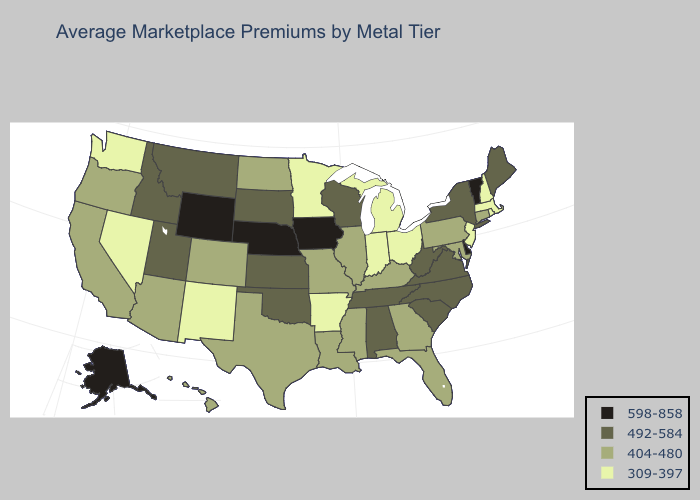Among the states that border New York , which have the highest value?
Give a very brief answer. Vermont. Which states have the highest value in the USA?
Give a very brief answer. Alaska, Delaware, Iowa, Nebraska, Vermont, Wyoming. Does Mississippi have a higher value than Virginia?
Answer briefly. No. Name the states that have a value in the range 404-480?
Quick response, please. Arizona, California, Colorado, Connecticut, Florida, Georgia, Hawaii, Illinois, Kentucky, Louisiana, Maryland, Mississippi, Missouri, North Dakota, Oregon, Pennsylvania, Texas. Does Indiana have the highest value in the MidWest?
Answer briefly. No. What is the value of Louisiana?
Short answer required. 404-480. Name the states that have a value in the range 309-397?
Keep it brief. Arkansas, Indiana, Massachusetts, Michigan, Minnesota, Nevada, New Hampshire, New Jersey, New Mexico, Ohio, Rhode Island, Washington. What is the value of New Mexico?
Quick response, please. 309-397. What is the value of Virginia?
Quick response, please. 492-584. Which states have the lowest value in the Northeast?
Keep it brief. Massachusetts, New Hampshire, New Jersey, Rhode Island. Name the states that have a value in the range 404-480?
Concise answer only. Arizona, California, Colorado, Connecticut, Florida, Georgia, Hawaii, Illinois, Kentucky, Louisiana, Maryland, Mississippi, Missouri, North Dakota, Oregon, Pennsylvania, Texas. Does the first symbol in the legend represent the smallest category?
Give a very brief answer. No. What is the highest value in the USA?
Keep it brief. 598-858. Which states hav the highest value in the Northeast?
Answer briefly. Vermont. Name the states that have a value in the range 598-858?
Short answer required. Alaska, Delaware, Iowa, Nebraska, Vermont, Wyoming. 